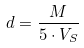Convert formula to latex. <formula><loc_0><loc_0><loc_500><loc_500>d = \frac { M } { 5 \cdot V _ { S } }</formula> 